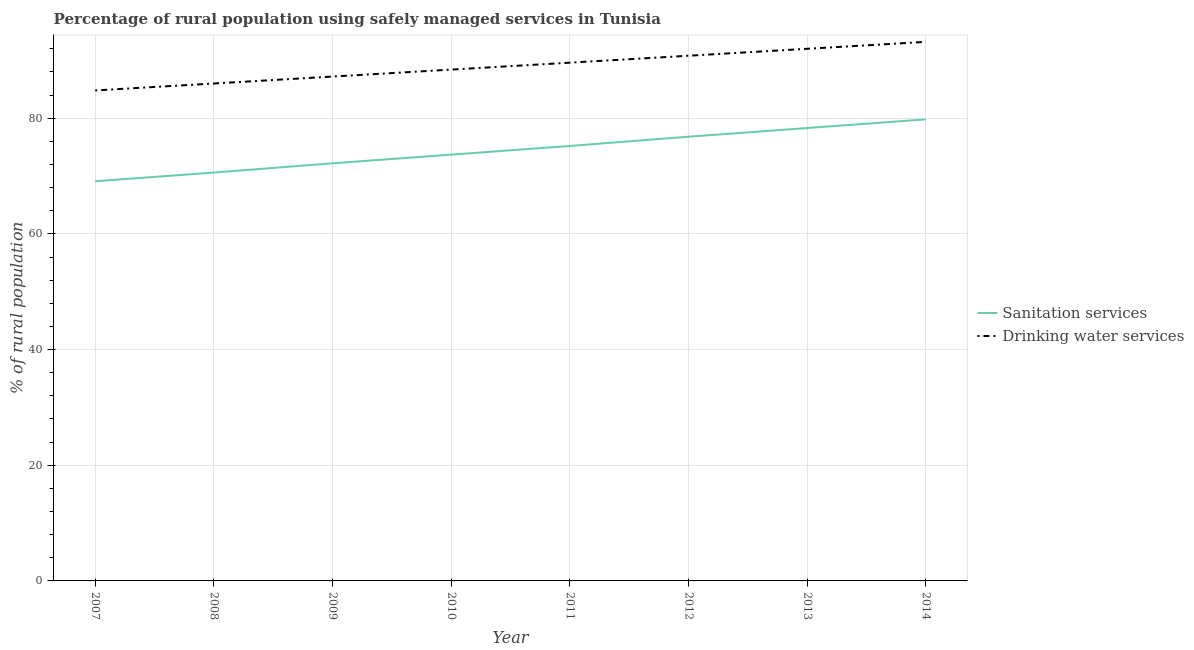How many different coloured lines are there?
Ensure brevity in your answer.  2. Does the line corresponding to percentage of rural population who used drinking water services intersect with the line corresponding to percentage of rural population who used sanitation services?
Provide a short and direct response. No. What is the percentage of rural population who used sanitation services in 2011?
Your answer should be compact. 75.2. Across all years, what is the maximum percentage of rural population who used sanitation services?
Your answer should be very brief. 79.8. Across all years, what is the minimum percentage of rural population who used drinking water services?
Your answer should be very brief. 84.8. What is the total percentage of rural population who used drinking water services in the graph?
Ensure brevity in your answer.  712. What is the difference between the percentage of rural population who used sanitation services in 2011 and that in 2012?
Offer a very short reply. -1.6. What is the difference between the percentage of rural population who used sanitation services in 2014 and the percentage of rural population who used drinking water services in 2009?
Offer a terse response. -7.4. What is the average percentage of rural population who used sanitation services per year?
Your response must be concise. 74.46. In the year 2007, what is the difference between the percentage of rural population who used sanitation services and percentage of rural population who used drinking water services?
Your response must be concise. -15.7. What is the ratio of the percentage of rural population who used sanitation services in 2011 to that in 2013?
Your response must be concise. 0.96. Is the percentage of rural population who used drinking water services in 2008 less than that in 2013?
Ensure brevity in your answer.  Yes. Is the difference between the percentage of rural population who used drinking water services in 2007 and 2014 greater than the difference between the percentage of rural population who used sanitation services in 2007 and 2014?
Give a very brief answer. Yes. What is the difference between the highest and the second highest percentage of rural population who used drinking water services?
Offer a very short reply. 1.2. What is the difference between the highest and the lowest percentage of rural population who used drinking water services?
Provide a short and direct response. 8.4. Does the percentage of rural population who used sanitation services monotonically increase over the years?
Give a very brief answer. Yes. Is the percentage of rural population who used drinking water services strictly less than the percentage of rural population who used sanitation services over the years?
Make the answer very short. No. How many lines are there?
Provide a succinct answer. 2. How many legend labels are there?
Ensure brevity in your answer.  2. How are the legend labels stacked?
Your response must be concise. Vertical. What is the title of the graph?
Ensure brevity in your answer.  Percentage of rural population using safely managed services in Tunisia. Does "National Tourists" appear as one of the legend labels in the graph?
Provide a succinct answer. No. What is the label or title of the X-axis?
Offer a terse response. Year. What is the label or title of the Y-axis?
Make the answer very short. % of rural population. What is the % of rural population of Sanitation services in 2007?
Your answer should be very brief. 69.1. What is the % of rural population of Drinking water services in 2007?
Offer a terse response. 84.8. What is the % of rural population of Sanitation services in 2008?
Your response must be concise. 70.6. What is the % of rural population in Sanitation services in 2009?
Offer a very short reply. 72.2. What is the % of rural population in Drinking water services in 2009?
Your response must be concise. 87.2. What is the % of rural population in Sanitation services in 2010?
Your answer should be compact. 73.7. What is the % of rural population of Drinking water services in 2010?
Provide a short and direct response. 88.4. What is the % of rural population of Sanitation services in 2011?
Your answer should be very brief. 75.2. What is the % of rural population in Drinking water services in 2011?
Ensure brevity in your answer.  89.6. What is the % of rural population of Sanitation services in 2012?
Your answer should be very brief. 76.8. What is the % of rural population in Drinking water services in 2012?
Make the answer very short. 90.8. What is the % of rural population in Sanitation services in 2013?
Your answer should be very brief. 78.3. What is the % of rural population of Drinking water services in 2013?
Offer a very short reply. 92. What is the % of rural population of Sanitation services in 2014?
Keep it short and to the point. 79.8. What is the % of rural population of Drinking water services in 2014?
Offer a very short reply. 93.2. Across all years, what is the maximum % of rural population in Sanitation services?
Ensure brevity in your answer.  79.8. Across all years, what is the maximum % of rural population in Drinking water services?
Keep it short and to the point. 93.2. Across all years, what is the minimum % of rural population in Sanitation services?
Provide a succinct answer. 69.1. Across all years, what is the minimum % of rural population in Drinking water services?
Your response must be concise. 84.8. What is the total % of rural population of Sanitation services in the graph?
Make the answer very short. 595.7. What is the total % of rural population of Drinking water services in the graph?
Give a very brief answer. 712. What is the difference between the % of rural population of Drinking water services in 2007 and that in 2008?
Provide a succinct answer. -1.2. What is the difference between the % of rural population in Sanitation services in 2007 and that in 2010?
Your answer should be very brief. -4.6. What is the difference between the % of rural population in Drinking water services in 2007 and that in 2010?
Make the answer very short. -3.6. What is the difference between the % of rural population of Sanitation services in 2007 and that in 2011?
Offer a very short reply. -6.1. What is the difference between the % of rural population of Drinking water services in 2007 and that in 2011?
Offer a terse response. -4.8. What is the difference between the % of rural population in Drinking water services in 2007 and that in 2014?
Your answer should be compact. -8.4. What is the difference between the % of rural population in Drinking water services in 2008 and that in 2009?
Your answer should be compact. -1.2. What is the difference between the % of rural population in Sanitation services in 2008 and that in 2012?
Give a very brief answer. -6.2. What is the difference between the % of rural population in Drinking water services in 2008 and that in 2012?
Give a very brief answer. -4.8. What is the difference between the % of rural population in Sanitation services in 2008 and that in 2013?
Provide a succinct answer. -7.7. What is the difference between the % of rural population in Drinking water services in 2008 and that in 2013?
Offer a very short reply. -6. What is the difference between the % of rural population of Sanitation services in 2008 and that in 2014?
Give a very brief answer. -9.2. What is the difference between the % of rural population in Drinking water services in 2008 and that in 2014?
Offer a very short reply. -7.2. What is the difference between the % of rural population in Sanitation services in 2009 and that in 2010?
Offer a terse response. -1.5. What is the difference between the % of rural population in Drinking water services in 2009 and that in 2010?
Ensure brevity in your answer.  -1.2. What is the difference between the % of rural population in Sanitation services in 2009 and that in 2012?
Your answer should be compact. -4.6. What is the difference between the % of rural population of Sanitation services in 2009 and that in 2013?
Provide a succinct answer. -6.1. What is the difference between the % of rural population of Drinking water services in 2009 and that in 2013?
Offer a very short reply. -4.8. What is the difference between the % of rural population in Sanitation services in 2009 and that in 2014?
Your answer should be very brief. -7.6. What is the difference between the % of rural population in Drinking water services in 2009 and that in 2014?
Your answer should be compact. -6. What is the difference between the % of rural population of Sanitation services in 2010 and that in 2012?
Offer a very short reply. -3.1. What is the difference between the % of rural population of Sanitation services in 2010 and that in 2013?
Your response must be concise. -4.6. What is the difference between the % of rural population in Drinking water services in 2010 and that in 2013?
Offer a very short reply. -3.6. What is the difference between the % of rural population of Drinking water services in 2010 and that in 2014?
Give a very brief answer. -4.8. What is the difference between the % of rural population in Sanitation services in 2011 and that in 2012?
Keep it short and to the point. -1.6. What is the difference between the % of rural population of Sanitation services in 2011 and that in 2013?
Offer a very short reply. -3.1. What is the difference between the % of rural population in Drinking water services in 2012 and that in 2013?
Provide a short and direct response. -1.2. What is the difference between the % of rural population in Drinking water services in 2012 and that in 2014?
Offer a very short reply. -2.4. What is the difference between the % of rural population of Sanitation services in 2007 and the % of rural population of Drinking water services in 2008?
Offer a terse response. -16.9. What is the difference between the % of rural population of Sanitation services in 2007 and the % of rural population of Drinking water services in 2009?
Offer a terse response. -18.1. What is the difference between the % of rural population in Sanitation services in 2007 and the % of rural population in Drinking water services in 2010?
Your answer should be very brief. -19.3. What is the difference between the % of rural population of Sanitation services in 2007 and the % of rural population of Drinking water services in 2011?
Provide a short and direct response. -20.5. What is the difference between the % of rural population in Sanitation services in 2007 and the % of rural population in Drinking water services in 2012?
Give a very brief answer. -21.7. What is the difference between the % of rural population of Sanitation services in 2007 and the % of rural population of Drinking water services in 2013?
Provide a succinct answer. -22.9. What is the difference between the % of rural population in Sanitation services in 2007 and the % of rural population in Drinking water services in 2014?
Make the answer very short. -24.1. What is the difference between the % of rural population of Sanitation services in 2008 and the % of rural population of Drinking water services in 2009?
Give a very brief answer. -16.6. What is the difference between the % of rural population in Sanitation services in 2008 and the % of rural population in Drinking water services in 2010?
Your answer should be very brief. -17.8. What is the difference between the % of rural population in Sanitation services in 2008 and the % of rural population in Drinking water services in 2012?
Ensure brevity in your answer.  -20.2. What is the difference between the % of rural population in Sanitation services in 2008 and the % of rural population in Drinking water services in 2013?
Give a very brief answer. -21.4. What is the difference between the % of rural population of Sanitation services in 2008 and the % of rural population of Drinking water services in 2014?
Ensure brevity in your answer.  -22.6. What is the difference between the % of rural population of Sanitation services in 2009 and the % of rural population of Drinking water services in 2010?
Provide a succinct answer. -16.2. What is the difference between the % of rural population in Sanitation services in 2009 and the % of rural population in Drinking water services in 2011?
Offer a very short reply. -17.4. What is the difference between the % of rural population of Sanitation services in 2009 and the % of rural population of Drinking water services in 2012?
Offer a terse response. -18.6. What is the difference between the % of rural population in Sanitation services in 2009 and the % of rural population in Drinking water services in 2013?
Your answer should be compact. -19.8. What is the difference between the % of rural population in Sanitation services in 2009 and the % of rural population in Drinking water services in 2014?
Provide a succinct answer. -21. What is the difference between the % of rural population of Sanitation services in 2010 and the % of rural population of Drinking water services in 2011?
Offer a very short reply. -15.9. What is the difference between the % of rural population in Sanitation services in 2010 and the % of rural population in Drinking water services in 2012?
Offer a terse response. -17.1. What is the difference between the % of rural population of Sanitation services in 2010 and the % of rural population of Drinking water services in 2013?
Make the answer very short. -18.3. What is the difference between the % of rural population of Sanitation services in 2010 and the % of rural population of Drinking water services in 2014?
Make the answer very short. -19.5. What is the difference between the % of rural population of Sanitation services in 2011 and the % of rural population of Drinking water services in 2012?
Keep it short and to the point. -15.6. What is the difference between the % of rural population in Sanitation services in 2011 and the % of rural population in Drinking water services in 2013?
Your answer should be compact. -16.8. What is the difference between the % of rural population in Sanitation services in 2012 and the % of rural population in Drinking water services in 2013?
Your answer should be very brief. -15.2. What is the difference between the % of rural population of Sanitation services in 2012 and the % of rural population of Drinking water services in 2014?
Provide a succinct answer. -16.4. What is the difference between the % of rural population of Sanitation services in 2013 and the % of rural population of Drinking water services in 2014?
Provide a succinct answer. -14.9. What is the average % of rural population of Sanitation services per year?
Give a very brief answer. 74.46. What is the average % of rural population in Drinking water services per year?
Offer a terse response. 89. In the year 2007, what is the difference between the % of rural population in Sanitation services and % of rural population in Drinking water services?
Your response must be concise. -15.7. In the year 2008, what is the difference between the % of rural population in Sanitation services and % of rural population in Drinking water services?
Ensure brevity in your answer.  -15.4. In the year 2009, what is the difference between the % of rural population in Sanitation services and % of rural population in Drinking water services?
Keep it short and to the point. -15. In the year 2010, what is the difference between the % of rural population in Sanitation services and % of rural population in Drinking water services?
Make the answer very short. -14.7. In the year 2011, what is the difference between the % of rural population of Sanitation services and % of rural population of Drinking water services?
Give a very brief answer. -14.4. In the year 2013, what is the difference between the % of rural population in Sanitation services and % of rural population in Drinking water services?
Offer a terse response. -13.7. In the year 2014, what is the difference between the % of rural population in Sanitation services and % of rural population in Drinking water services?
Your answer should be very brief. -13.4. What is the ratio of the % of rural population in Sanitation services in 2007 to that in 2008?
Give a very brief answer. 0.98. What is the ratio of the % of rural population of Sanitation services in 2007 to that in 2009?
Offer a very short reply. 0.96. What is the ratio of the % of rural population in Drinking water services in 2007 to that in 2009?
Provide a succinct answer. 0.97. What is the ratio of the % of rural population of Sanitation services in 2007 to that in 2010?
Give a very brief answer. 0.94. What is the ratio of the % of rural population of Drinking water services in 2007 to that in 2010?
Make the answer very short. 0.96. What is the ratio of the % of rural population of Sanitation services in 2007 to that in 2011?
Your answer should be compact. 0.92. What is the ratio of the % of rural population in Drinking water services in 2007 to that in 2011?
Offer a terse response. 0.95. What is the ratio of the % of rural population in Sanitation services in 2007 to that in 2012?
Ensure brevity in your answer.  0.9. What is the ratio of the % of rural population in Drinking water services in 2007 to that in 2012?
Your response must be concise. 0.93. What is the ratio of the % of rural population in Sanitation services in 2007 to that in 2013?
Make the answer very short. 0.88. What is the ratio of the % of rural population of Drinking water services in 2007 to that in 2013?
Keep it short and to the point. 0.92. What is the ratio of the % of rural population of Sanitation services in 2007 to that in 2014?
Make the answer very short. 0.87. What is the ratio of the % of rural population of Drinking water services in 2007 to that in 2014?
Offer a terse response. 0.91. What is the ratio of the % of rural population of Sanitation services in 2008 to that in 2009?
Provide a short and direct response. 0.98. What is the ratio of the % of rural population in Drinking water services in 2008 to that in 2009?
Make the answer very short. 0.99. What is the ratio of the % of rural population in Sanitation services in 2008 to that in 2010?
Offer a terse response. 0.96. What is the ratio of the % of rural population of Drinking water services in 2008 to that in 2010?
Keep it short and to the point. 0.97. What is the ratio of the % of rural population in Sanitation services in 2008 to that in 2011?
Make the answer very short. 0.94. What is the ratio of the % of rural population in Drinking water services in 2008 to that in 2011?
Your answer should be compact. 0.96. What is the ratio of the % of rural population in Sanitation services in 2008 to that in 2012?
Your response must be concise. 0.92. What is the ratio of the % of rural population of Drinking water services in 2008 to that in 2012?
Offer a terse response. 0.95. What is the ratio of the % of rural population of Sanitation services in 2008 to that in 2013?
Your answer should be compact. 0.9. What is the ratio of the % of rural population of Drinking water services in 2008 to that in 2013?
Your response must be concise. 0.93. What is the ratio of the % of rural population in Sanitation services in 2008 to that in 2014?
Offer a terse response. 0.88. What is the ratio of the % of rural population in Drinking water services in 2008 to that in 2014?
Offer a very short reply. 0.92. What is the ratio of the % of rural population in Sanitation services in 2009 to that in 2010?
Offer a terse response. 0.98. What is the ratio of the % of rural population of Drinking water services in 2009 to that in 2010?
Offer a terse response. 0.99. What is the ratio of the % of rural population in Sanitation services in 2009 to that in 2011?
Provide a short and direct response. 0.96. What is the ratio of the % of rural population in Drinking water services in 2009 to that in 2011?
Your answer should be compact. 0.97. What is the ratio of the % of rural population of Sanitation services in 2009 to that in 2012?
Offer a terse response. 0.94. What is the ratio of the % of rural population in Drinking water services in 2009 to that in 2012?
Your response must be concise. 0.96. What is the ratio of the % of rural population in Sanitation services in 2009 to that in 2013?
Your response must be concise. 0.92. What is the ratio of the % of rural population of Drinking water services in 2009 to that in 2013?
Provide a succinct answer. 0.95. What is the ratio of the % of rural population of Sanitation services in 2009 to that in 2014?
Make the answer very short. 0.9. What is the ratio of the % of rural population in Drinking water services in 2009 to that in 2014?
Offer a very short reply. 0.94. What is the ratio of the % of rural population of Sanitation services in 2010 to that in 2011?
Your answer should be compact. 0.98. What is the ratio of the % of rural population in Drinking water services in 2010 to that in 2011?
Offer a very short reply. 0.99. What is the ratio of the % of rural population in Sanitation services in 2010 to that in 2012?
Make the answer very short. 0.96. What is the ratio of the % of rural population of Drinking water services in 2010 to that in 2012?
Offer a terse response. 0.97. What is the ratio of the % of rural population of Sanitation services in 2010 to that in 2013?
Your answer should be very brief. 0.94. What is the ratio of the % of rural population of Drinking water services in 2010 to that in 2013?
Offer a very short reply. 0.96. What is the ratio of the % of rural population of Sanitation services in 2010 to that in 2014?
Provide a succinct answer. 0.92. What is the ratio of the % of rural population in Drinking water services in 2010 to that in 2014?
Keep it short and to the point. 0.95. What is the ratio of the % of rural population of Sanitation services in 2011 to that in 2012?
Your answer should be compact. 0.98. What is the ratio of the % of rural population in Drinking water services in 2011 to that in 2012?
Your response must be concise. 0.99. What is the ratio of the % of rural population of Sanitation services in 2011 to that in 2013?
Give a very brief answer. 0.96. What is the ratio of the % of rural population of Drinking water services in 2011 to that in 2013?
Provide a short and direct response. 0.97. What is the ratio of the % of rural population in Sanitation services in 2011 to that in 2014?
Offer a terse response. 0.94. What is the ratio of the % of rural population of Drinking water services in 2011 to that in 2014?
Offer a terse response. 0.96. What is the ratio of the % of rural population of Sanitation services in 2012 to that in 2013?
Ensure brevity in your answer.  0.98. What is the ratio of the % of rural population of Sanitation services in 2012 to that in 2014?
Keep it short and to the point. 0.96. What is the ratio of the % of rural population in Drinking water services in 2012 to that in 2014?
Your answer should be very brief. 0.97. What is the ratio of the % of rural population of Sanitation services in 2013 to that in 2014?
Keep it short and to the point. 0.98. What is the ratio of the % of rural population of Drinking water services in 2013 to that in 2014?
Provide a short and direct response. 0.99. What is the difference between the highest and the lowest % of rural population of Drinking water services?
Provide a short and direct response. 8.4. 